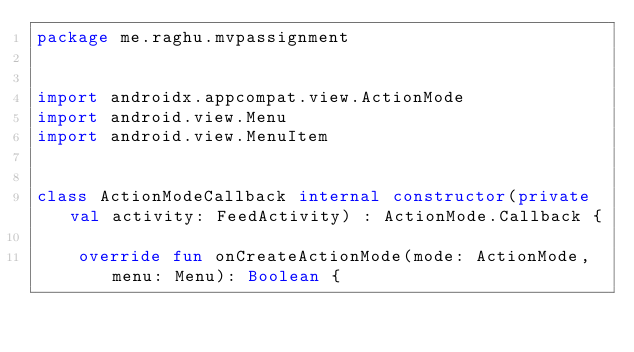<code> <loc_0><loc_0><loc_500><loc_500><_Kotlin_>package me.raghu.mvpassignment


import androidx.appcompat.view.ActionMode
import android.view.Menu
import android.view.MenuItem


class ActionModeCallback internal constructor(private val activity: FeedActivity) : ActionMode.Callback {

    override fun onCreateActionMode(mode: ActionMode, menu: Menu): Boolean {</code> 